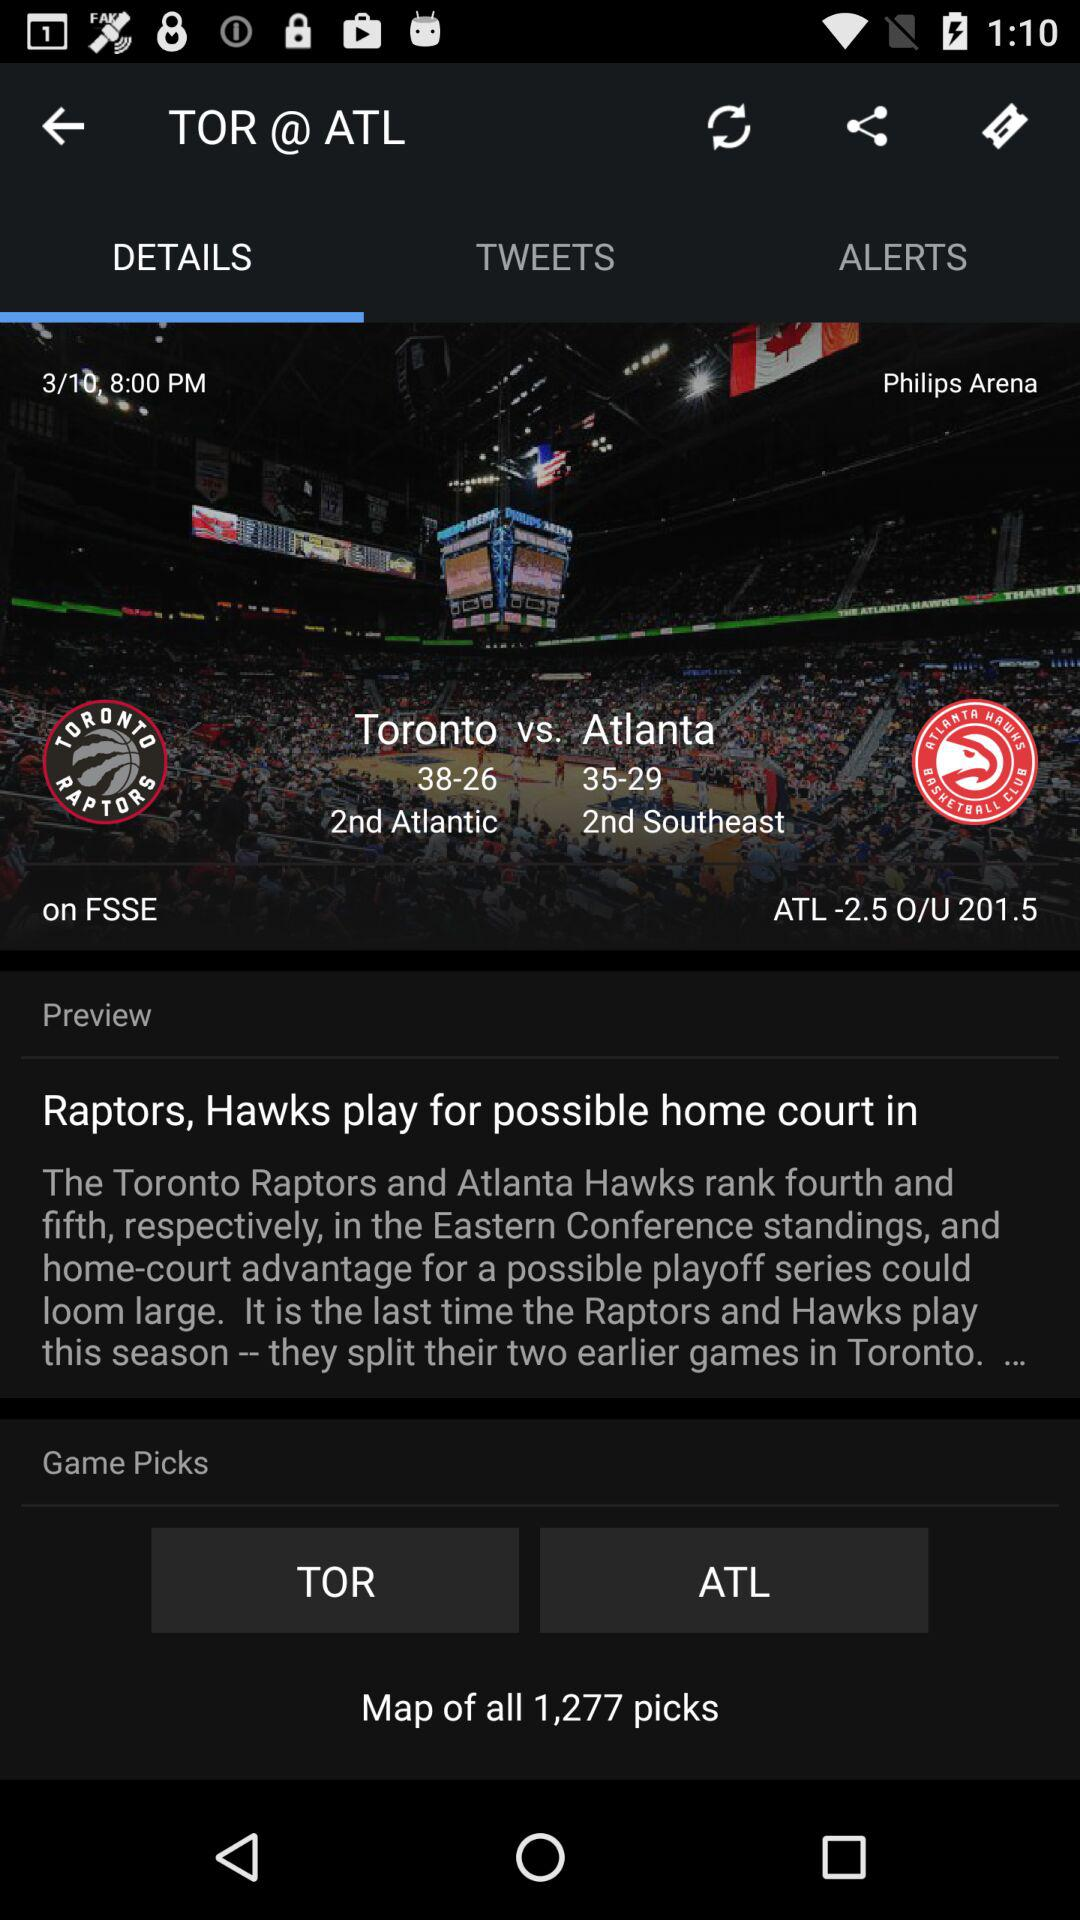How many picks are there in total? There are 1,277 picks in total. 